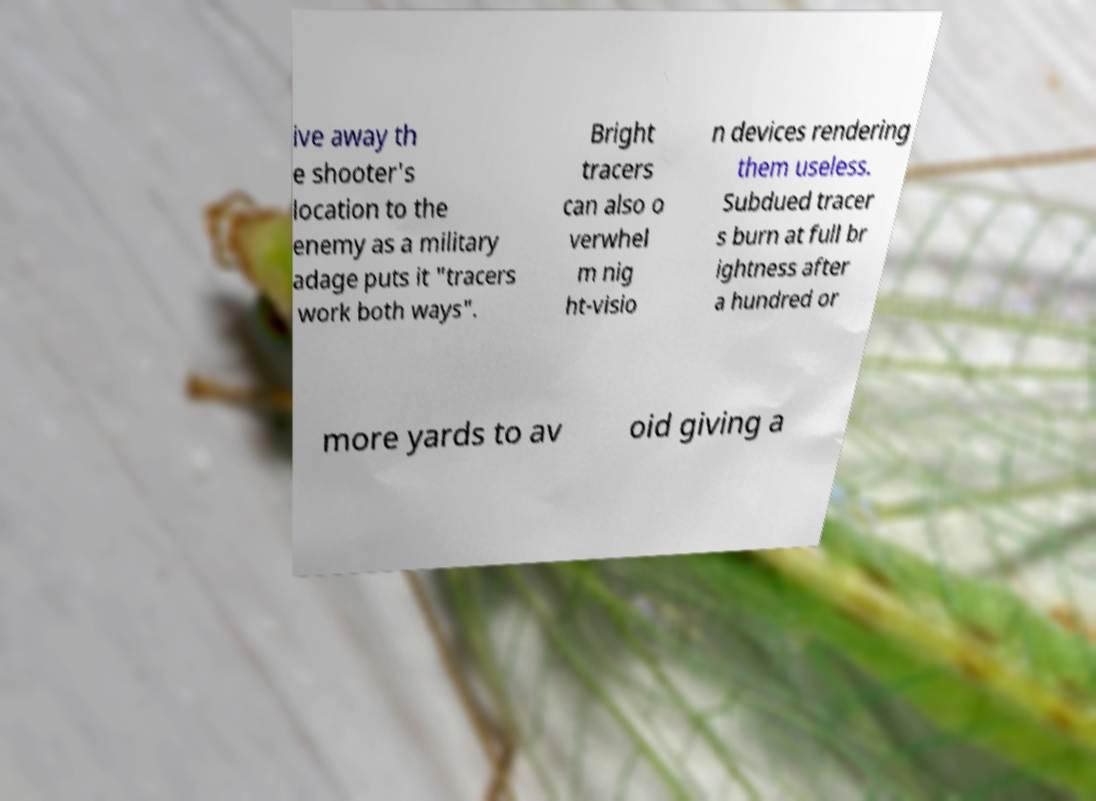What messages or text are displayed in this image? I need them in a readable, typed format. ive away th e shooter's location to the enemy as a military adage puts it "tracers work both ways". Bright tracers can also o verwhel m nig ht-visio n devices rendering them useless. Subdued tracer s burn at full br ightness after a hundred or more yards to av oid giving a 